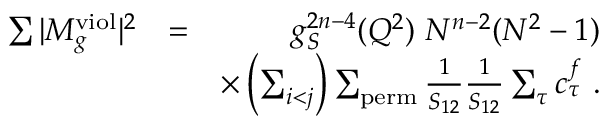Convert formula to latex. <formula><loc_0><loc_0><loc_500><loc_500>\begin{array} { r l r } { \sum | M _ { g } ^ { v i o l } | ^ { 2 } } & { = } & { g _ { S } ^ { 2 n - 4 } ( Q ^ { 2 } ) N ^ { n - 2 } ( N ^ { 2 } - 1 ) } \\ & { \times \left ( \sum _ { i < j } \right ) \sum _ { p e r m } \frac { 1 } { S _ { 1 2 } } \frac { 1 } { S _ { 1 2 } } \sum _ { \tau } c _ { \tau } ^ { f } . } \end{array}</formula> 